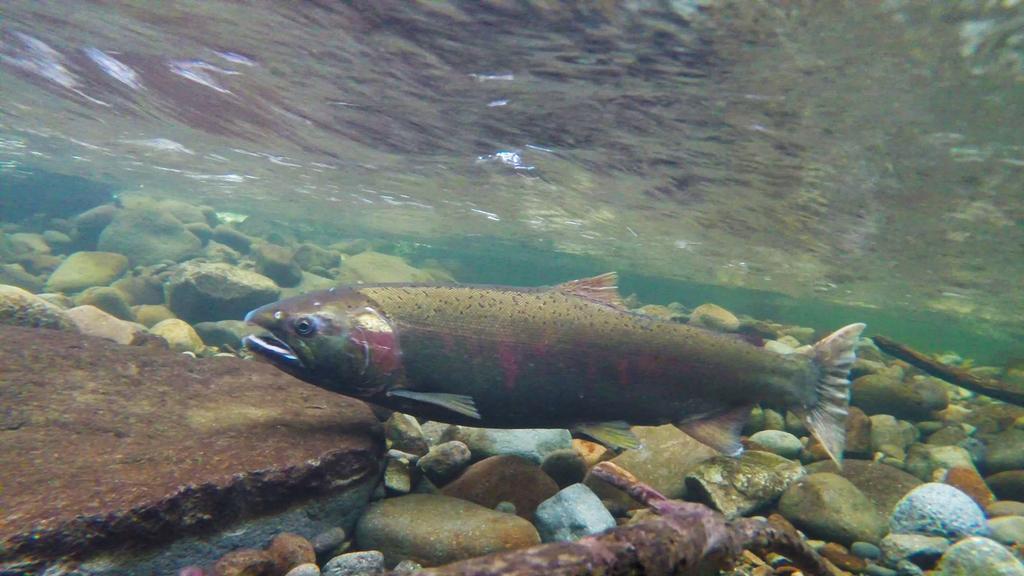Please provide a concise description of this image. This is an image clicked inside the water. Here I can see a fish which is facing towards the left side. At the bottom of the image I can see many stones. 